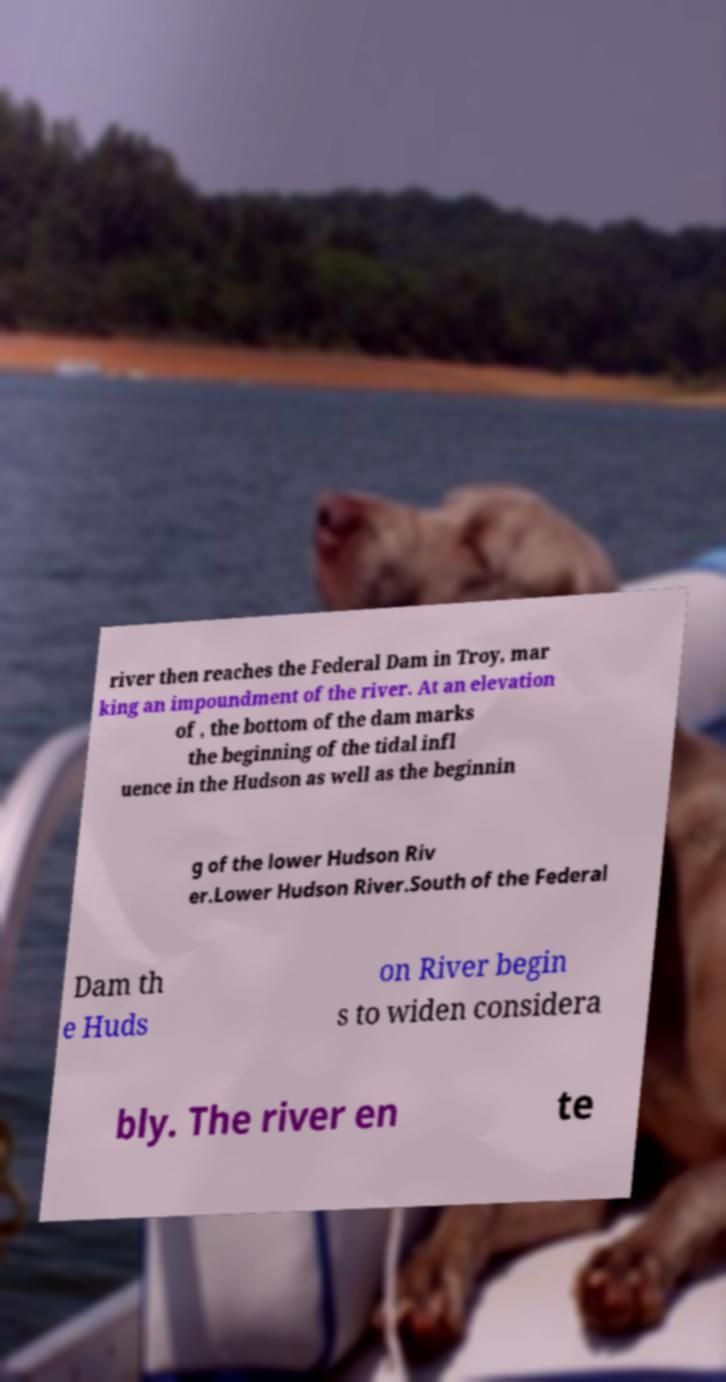Please identify and transcribe the text found in this image. river then reaches the Federal Dam in Troy, mar king an impoundment of the river. At an elevation of , the bottom of the dam marks the beginning of the tidal infl uence in the Hudson as well as the beginnin g of the lower Hudson Riv er.Lower Hudson River.South of the Federal Dam th e Huds on River begin s to widen considera bly. The river en te 